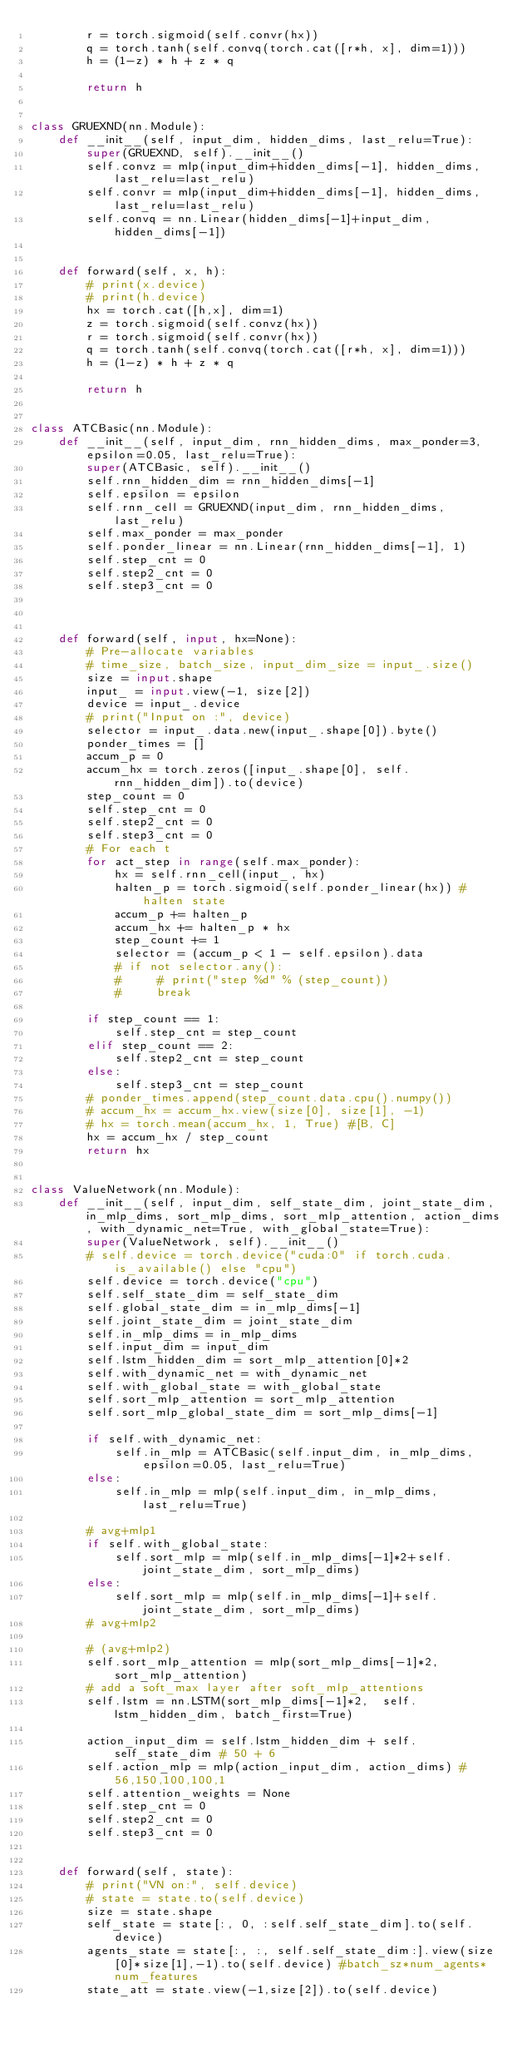Convert code to text. <code><loc_0><loc_0><loc_500><loc_500><_Python_>        r = torch.sigmoid(self.convr(hx))
        q = torch.tanh(self.convq(torch.cat([r*h, x], dim=1)))
        h = (1-z) * h + z * q

        return h


class GRUEXND(nn.Module):
    def __init__(self, input_dim, hidden_dims, last_relu=True):
        super(GRUEXND, self).__init__()
        self.convz = mlp(input_dim+hidden_dims[-1], hidden_dims, last_relu=last_relu)
        self.convr = mlp(input_dim+hidden_dims[-1], hidden_dims, last_relu=last_relu)
        self.convq = nn.Linear(hidden_dims[-1]+input_dim, hidden_dims[-1])


    def forward(self, x, h):
        # print(x.device)
        # print(h.device)
        hx = torch.cat([h,x], dim=1)
        z = torch.sigmoid(self.convz(hx))
        r = torch.sigmoid(self.convr(hx))
        q = torch.tanh(self.convq(torch.cat([r*h, x], dim=1)))
        h = (1-z) * h + z * q

        return h


class ATCBasic(nn.Module):
    def __init__(self, input_dim, rnn_hidden_dims, max_ponder=3, epsilon=0.05, last_relu=True):
        super(ATCBasic, self).__init__()
        self.rnn_hidden_dim = rnn_hidden_dims[-1]
        self.epsilon = epsilon
        self.rnn_cell = GRUEXND(input_dim, rnn_hidden_dims, last_relu)
        self.max_ponder = max_ponder
        self.ponder_linear = nn.Linear(rnn_hidden_dims[-1], 1)
        self.step_cnt = 0
        self.step2_cnt = 0
        self.step3_cnt = 0

    
    
    def forward(self, input, hx=None):
        # Pre-allocate variables
        # time_size, batch_size, input_dim_size = input_.size()
        size = input.shape
        input_ = input.view(-1, size[2])
        device = input_.device
        # print("Input on :", device)
        selector = input_.data.new(input_.shape[0]).byte()
        ponder_times = []
        accum_p = 0
        accum_hx = torch.zeros([input_.shape[0], self.rnn_hidden_dim]).to(device)
        step_count = 0
        self.step_cnt = 0
        self.step2_cnt = 0
        self.step3_cnt = 0
        # For each t
        for act_step in range(self.max_ponder):
            hx = self.rnn_cell(input_, hx)
            halten_p = torch.sigmoid(self.ponder_linear(hx)) # halten state
            accum_p += halten_p
            accum_hx += halten_p * hx
            step_count += 1
            selector = (accum_p < 1 - self.epsilon).data
            # if not selector.any():
            #     # print("step %d" % (step_count))
            #     break

        if step_count == 1:
            self.step_cnt = step_count
        elif step_count == 2:
            self.step2_cnt = step_count
        else:
            self.step3_cnt = step_count
        # ponder_times.append(step_count.data.cpu().numpy())
        # accum_hx = accum_hx.view(size[0], size[1], -1)
        # hx = torch.mean(accum_hx, 1, True) #[B, C]
        hx = accum_hx / step_count
        return hx


class ValueNetwork(nn.Module):
    def __init__(self, input_dim, self_state_dim, joint_state_dim, in_mlp_dims, sort_mlp_dims, sort_mlp_attention, action_dims, with_dynamic_net=True, with_global_state=True):
        super(ValueNetwork, self).__init__()
        # self.device = torch.device("cuda:0" if torch.cuda.is_available() else "cpu")
        self.device = torch.device("cpu")
        self.self_state_dim = self_state_dim
        self.global_state_dim = in_mlp_dims[-1]
        self.joint_state_dim = joint_state_dim
        self.in_mlp_dims = in_mlp_dims
        self.input_dim = input_dim
        self.lstm_hidden_dim = sort_mlp_attention[0]*2
        self.with_dynamic_net = with_dynamic_net
        self.with_global_state = with_global_state
        self.sort_mlp_attention = sort_mlp_attention
        self.sort_mlp_global_state_dim = sort_mlp_dims[-1]

        if self.with_dynamic_net:
            self.in_mlp = ATCBasic(self.input_dim, in_mlp_dims, epsilon=0.05, last_relu=True)
        else:
            self.in_mlp = mlp(self.input_dim, in_mlp_dims, last_relu=True)

        # avg+mlp1
        if self.with_global_state:
            self.sort_mlp = mlp(self.in_mlp_dims[-1]*2+self.joint_state_dim, sort_mlp_dims)     
        else:
            self.sort_mlp = mlp(self.in_mlp_dims[-1]+self.joint_state_dim, sort_mlp_dims)
        # avg+mlp2

        # (avg+mlp2)
        self.sort_mlp_attention = mlp(sort_mlp_dims[-1]*2, sort_mlp_attention)
        # add a soft_max layer after soft_mlp_attentions
        self.lstm = nn.LSTM(sort_mlp_dims[-1]*2,  self.lstm_hidden_dim, batch_first=True)

        action_input_dim = self.lstm_hidden_dim + self.self_state_dim # 50 + 6
        self.action_mlp = mlp(action_input_dim, action_dims) #56,150,100,100,1
        self.attention_weights = None
        self.step_cnt = 0
        self.step2_cnt = 0
        self.step3_cnt = 0


    def forward(self, state):
        # print("VN on:", self.device)
        # state = state.to(self.device)
        size = state.shape
        self_state = state[:, 0, :self.self_state_dim].to(self.device)
        agents_state = state[:, :, self.self_state_dim:].view(size[0]*size[1],-1).to(self.device) #batch_sz*num_agents*num_features
        state_att = state.view(-1,size[2]).to(self.device)
</code> 